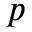Convert formula to latex. <formula><loc_0><loc_0><loc_500><loc_500>p</formula> 